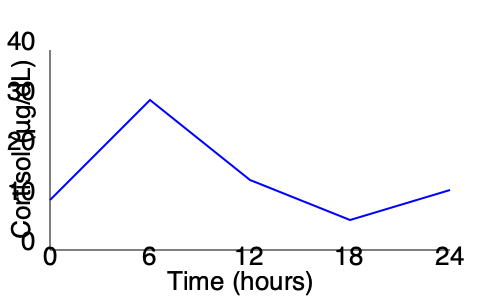A 45-year-old patient presents with symptoms suggestive of Cushing's syndrome. You order a 24-hour urine collection for cortisol measurement. The graph shows the cortisol levels over the 24-hour period. What potential issue with the collection process could explain the unusual pattern observed, and how might this affect the interpretation of the results? To analyze this graph and identify potential issues, let's follow these steps:

1. Normal cortisol pattern: In a typical 24-hour cycle, cortisol levels are highest in the early morning (around 6-8 AM) and lowest at night. The graph should show a peak in the early hours and a gradual decline throughout the day.

2. Observed pattern: The graph shows an atypical pattern with:
   - A low level at the start (0 hours)
   - A peak at around 6 hours
   - Fluctuations throughout the rest of the period

3. Potential issue: The most likely explanation for this unusual pattern is improper timing of the urine collection. It appears that the collection may have started in the afternoon or evening, rather than in the morning as typically recommended.

4. Evidence for improper timing:
   - The low initial level suggests the collection started when cortisol was naturally low (evening/night).
   - The peak at 6 hours likely represents the normal morning cortisol surge.
   - The subsequent fluctuations are consistent with daytime variations.

5. Impact on interpretation:
   - The total 24-hour cortisol excretion may still be accurate if the full 24 hours were collected.
   - However, the pattern is shifted, which could lead to misinterpretation of the diurnal rhythm.
   - This could potentially mask or exaggerate circadian rhythm abnormalities associated with Cushing's syndrome.

6. Recommendation:
   - The test should be repeated with proper instructions for timing the collection.
   - The patient should be advised to start the collection with the second morning void and continue for exactly 24 hours.

In conclusion, the unusual pattern is likely due to improper timing of the urine collection, which could lead to misinterpretation of the cortisol rhythm, potentially affecting the diagnosis of Cushing's syndrome.
Answer: Improper timing of urine collection, starting in the afternoon/evening instead of morning. 